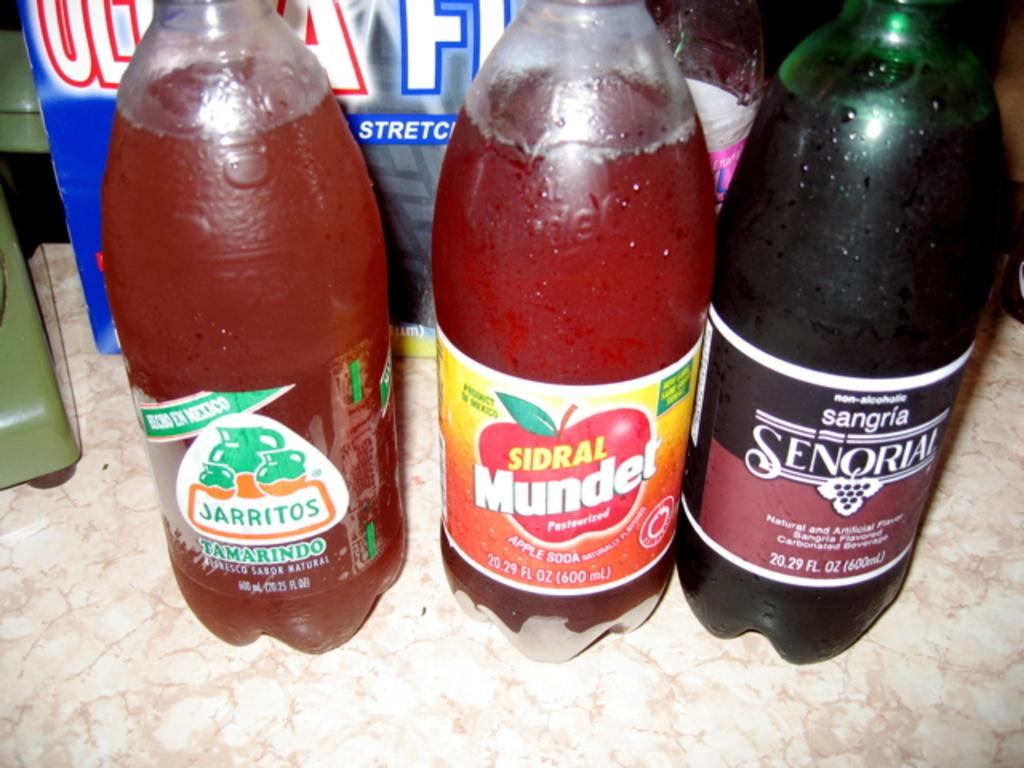What type of furniture is present in the image? There is a table in the image. What objects are placed on the table? There are three bottles on the table. What is written on the bottles? The bottles are labeled as "tamarindo." Can you describe any other objects or colors in the background of the image? There is a pink color bag in the background of the image. What religion is practiced by the people in the image? There are no people visible in the image, so it is impossible to determine the religion practiced by anyone in the image. 